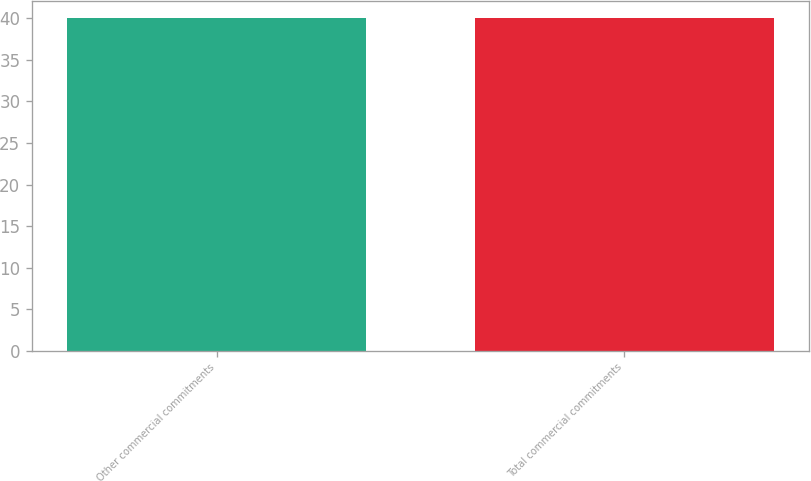Convert chart. <chart><loc_0><loc_0><loc_500><loc_500><bar_chart><fcel>Other commercial commitments<fcel>Total commercial commitments<nl><fcel>40<fcel>40.1<nl></chart> 